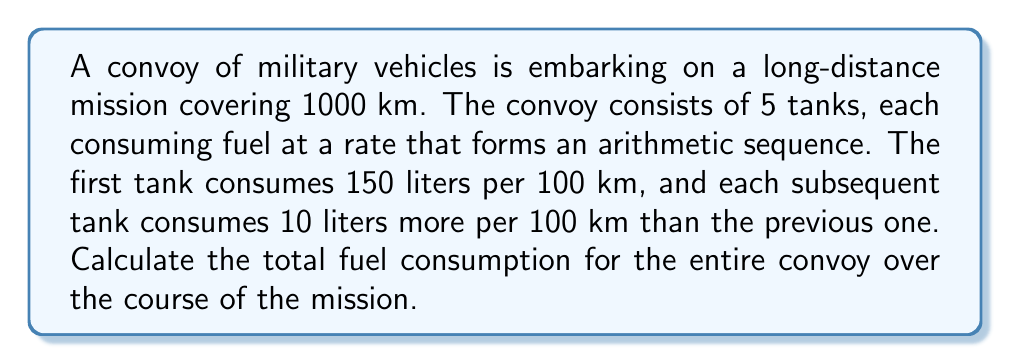Give your solution to this math problem. Let's approach this step-by-step:

1) First, let's identify the fuel consumption rates for each tank:
   Tank 1: 150 L/100km
   Tank 2: 160 L/100km
   Tank 3: 170 L/100km
   Tank 4: 180 L/100km
   Tank 5: 190 L/100km

2) This forms an arithmetic sequence with:
   $a_1 = 150$ (first term)
   $d = 10$ (common difference)
   $n = 5$ (number of terms)

3) The sum of an arithmetic sequence is given by:
   $$S_n = \frac{n}{2}(a_1 + a_n)$$
   where $a_n = a_1 + (n-1)d$

4) Calculate $a_n$:
   $a_5 = 150 + (5-1)10 = 190$

5) Now we can calculate the sum:
   $$S_5 = \frac{5}{2}(150 + 190) = \frac{5}{2}(340) = 850$$

6) This sum represents the total fuel consumption for 100 km.

7) For the full 1000 km mission, we multiply by 10:
   $850 * 10 = 8500$ liters

Therefore, the total fuel consumption for the entire convoy over the 1000 km mission is 8500 liters.
Answer: 8500 liters 